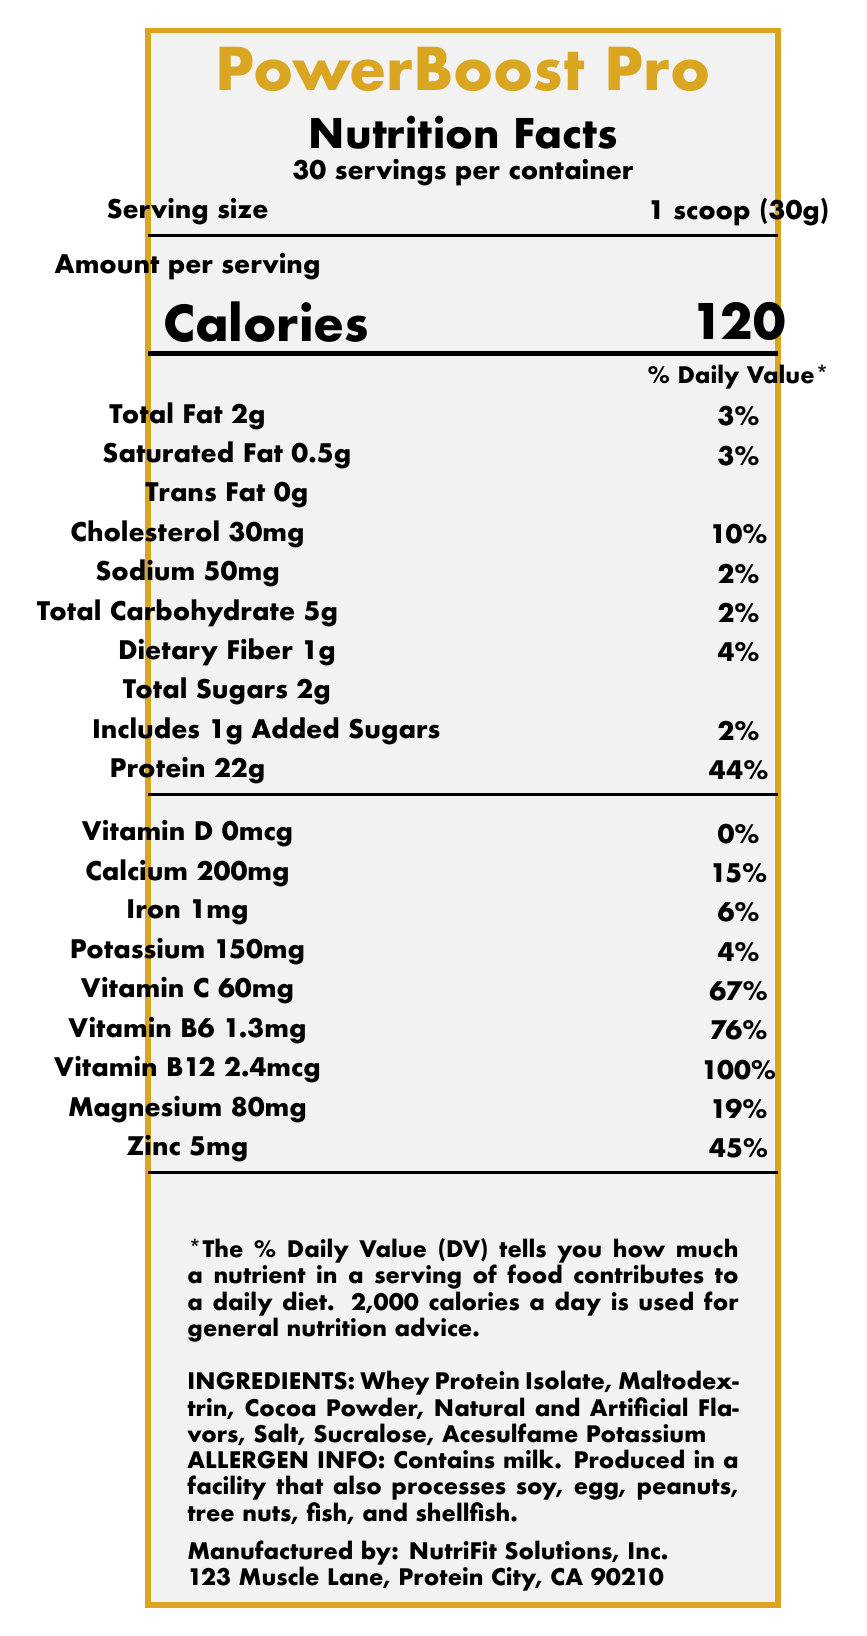What is the serving size of PowerBoost Pro? The serving size is explicitly stated as "1 scoop (30g)" on the nutrition facts label.
Answer: 1 scoop (30g) How many calories are in one serving of PowerBoost Pro? The document specifies that each serving contains 120 calories.
Answer: 120 What is the percentage of the daily value for protein per serving? The percentage of the daily value for protein per serving is given as 44%.
Answer: 44% Name three minerals included in PowerBoost Pro. The minerals included in PowerBoost Pro are listed under the nutrient section: Calcium, Iron, and Magnesium.
Answer: Calcium, Iron, Magnesium Does PowerBoost Pro contain any added sugars? The document shows that PowerBoost Pro contains 1g of added sugars per serving.
Answer: Yes Which of the following nutrients has the highest percentage of daily value in PowerBoost Pro? A. Calcium B. Vitamin C C. Vitamin B12 D. Zinc The document indicates that Vitamin B12 has 100% of the daily value per serving, the highest among listed nutrients.
Answer: C. Vitamin B12 What color scheme is used in the PowerBoost Pro packaging? A. Blue and White B. Red and Black C. Gold and Black D. Green and Yellow The color scheme used is gold and black, as specified in the document.
Answer: C. Gold and Black Which company manufactures PowerBoost Pro? A. MuscleMakers Inc. B. NutriFit Solutions, Inc. C. HealthBoosters D. ProteinPros The document states that PowerBoost Pro is manufactured by NutriFit Solutions, Inc.
Answer: B. NutriFit Solutions, Inc. Is PowerBoost Pro intended to diagnose, treat, cure, or prevent any disease? The disclaimer in the document clearly states that the product is not intended to diagnose, treat, cure, or prevent any disease.
Answer: No Summarize the main details provided in the document. The document contains a detailed nutrition label showing information like serving size, various nutrient amounts, and percentages of daily values, along with additional information such as ingredients, allergen advisories, and company information.
Answer: The document describes the nutrition facts label for PowerBoost Pro, including serving size, nutrient content per serving, ingredients, allergen information, manufacturer details, and disclaimer. It also highlights trademark concerns related to the use of similar fonts and color schemes to a competitor's brand. What is the recommended daily calorie intake used for general nutrition advice in the document? The document states that 2,000 calories a day is used for general nutrition advice.
Answer: 2,000 calories What is the manufacturer address of NutriFit Solutions, Inc.? The manufacturer's address is clearly listed as 123 Muscle Lane, Protein City, CA 90210.
Answer: 123 Muscle Lane, Protein City, CA 90210 What is the cholesterol content per serving of PowerBoost Pro? The cholesterol content per serving is given as 30mg on the label.
Answer: 30mg Are there any ingredients in PowerBoost Pro that might cause allergies? The document mentions that the product contains milk and is produced in a facility that also processes soy, egg, peanuts, tree nuts, fish, and shellfish.
Answer: Yes Is the product produced in a facility that processes peanuts? The allergen info section indicates that the product is produced in a facility that processes peanuts among other allergens.
Answer: Yes How does the product visually distinguish its calories and daily values? The nutrition facts label uses bold, large fonts to make key information like calories and daily values stand out.
Answer: By using bold and large fonts What similar competitor product might the PowerBoost Pro resemble, based on the document? The document mentions a similar font and color scheme to OptimumNutrition's Gold Standard line.
Answer: OptimumNutrition What is the exact amount of Vitamin B6 per serving? The label specifies that each serving contains 1.3mg of Vitamin B6.
Answer: 1.3mg Why does the document mention trademark concerns? The document refers to the visual similarity to a competitor's brand but does not provide evidence as to whether the similarities were intentional or the extent of potential consumer confusion.
Answer: Cannot be determined 